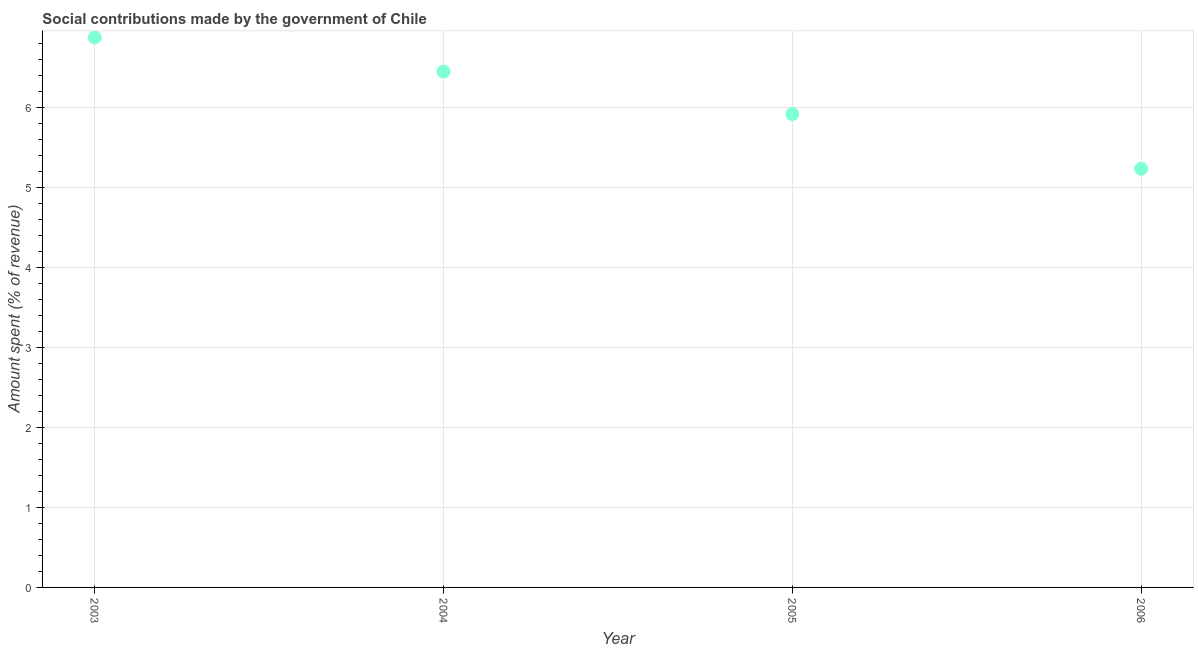What is the amount spent in making social contributions in 2006?
Your response must be concise. 5.23. Across all years, what is the maximum amount spent in making social contributions?
Your answer should be compact. 6.88. Across all years, what is the minimum amount spent in making social contributions?
Your response must be concise. 5.23. In which year was the amount spent in making social contributions maximum?
Your answer should be compact. 2003. What is the sum of the amount spent in making social contributions?
Give a very brief answer. 24.48. What is the difference between the amount spent in making social contributions in 2003 and 2005?
Your answer should be very brief. 0.96. What is the average amount spent in making social contributions per year?
Give a very brief answer. 6.12. What is the median amount spent in making social contributions?
Offer a terse response. 6.18. In how many years, is the amount spent in making social contributions greater than 2.8 %?
Keep it short and to the point. 4. Do a majority of the years between 2003 and 2006 (inclusive) have amount spent in making social contributions greater than 0.6000000000000001 %?
Your answer should be compact. Yes. What is the ratio of the amount spent in making social contributions in 2005 to that in 2006?
Give a very brief answer. 1.13. What is the difference between the highest and the second highest amount spent in making social contributions?
Your response must be concise. 0.43. What is the difference between the highest and the lowest amount spent in making social contributions?
Your answer should be compact. 1.64. In how many years, is the amount spent in making social contributions greater than the average amount spent in making social contributions taken over all years?
Your response must be concise. 2. How many years are there in the graph?
Your answer should be very brief. 4. Are the values on the major ticks of Y-axis written in scientific E-notation?
Your response must be concise. No. What is the title of the graph?
Your answer should be compact. Social contributions made by the government of Chile. What is the label or title of the X-axis?
Your response must be concise. Year. What is the label or title of the Y-axis?
Make the answer very short. Amount spent (% of revenue). What is the Amount spent (% of revenue) in 2003?
Offer a very short reply. 6.88. What is the Amount spent (% of revenue) in 2004?
Your response must be concise. 6.45. What is the Amount spent (% of revenue) in 2005?
Provide a short and direct response. 5.92. What is the Amount spent (% of revenue) in 2006?
Your answer should be very brief. 5.23. What is the difference between the Amount spent (% of revenue) in 2003 and 2004?
Give a very brief answer. 0.43. What is the difference between the Amount spent (% of revenue) in 2003 and 2005?
Keep it short and to the point. 0.96. What is the difference between the Amount spent (% of revenue) in 2003 and 2006?
Ensure brevity in your answer.  1.64. What is the difference between the Amount spent (% of revenue) in 2004 and 2005?
Provide a short and direct response. 0.53. What is the difference between the Amount spent (% of revenue) in 2004 and 2006?
Your answer should be compact. 1.22. What is the difference between the Amount spent (% of revenue) in 2005 and 2006?
Your answer should be very brief. 0.68. What is the ratio of the Amount spent (% of revenue) in 2003 to that in 2004?
Give a very brief answer. 1.07. What is the ratio of the Amount spent (% of revenue) in 2003 to that in 2005?
Offer a very short reply. 1.16. What is the ratio of the Amount spent (% of revenue) in 2003 to that in 2006?
Ensure brevity in your answer.  1.31. What is the ratio of the Amount spent (% of revenue) in 2004 to that in 2005?
Give a very brief answer. 1.09. What is the ratio of the Amount spent (% of revenue) in 2004 to that in 2006?
Your answer should be very brief. 1.23. What is the ratio of the Amount spent (% of revenue) in 2005 to that in 2006?
Your answer should be compact. 1.13. 